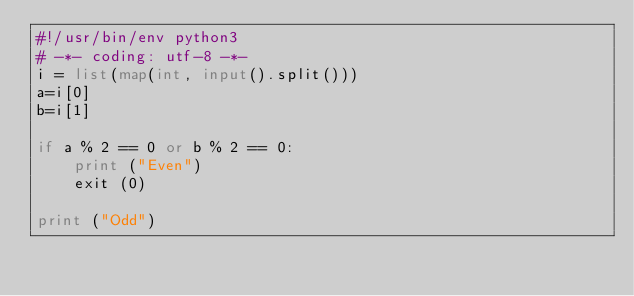Convert code to text. <code><loc_0><loc_0><loc_500><loc_500><_Python_>#!/usr/bin/env python3
# -*- coding: utf-8 -*-
i = list(map(int, input().split()))
a=i[0]
b=i[1]

if a % 2 == 0 or b % 2 == 0:
    print ("Even")
    exit (0)

print ("Odd")</code> 